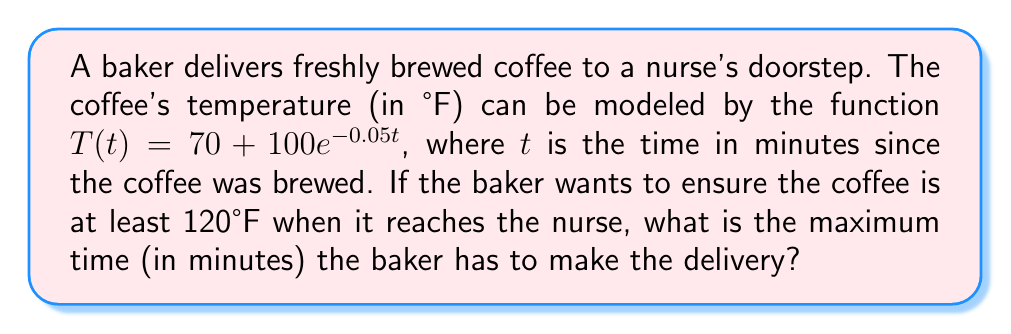What is the answer to this math problem? 1) We need to solve the equation $T(t) = 120$ to find the time when the coffee reaches 120°F.

2) Substitute the given function:
   $70 + 100e^{-0.05t} = 120$

3) Subtract 70 from both sides:
   $100e^{-0.05t} = 50$

4) Divide both sides by 100:
   $e^{-0.05t} = 0.5$

5) Take the natural logarithm of both sides:
   $\ln(e^{-0.05t}) = \ln(0.5)$

6) Simplify the left side using the property of logarithms:
   $-0.05t = \ln(0.5)$

7) Divide both sides by -0.05:
   $t = \frac{\ln(0.5)}{-0.05}$

8) Calculate the result:
   $t \approx 13.86$ minutes

9) Since we want the maximum time, we round down to ensure the temperature is at least 120°F.

Therefore, the baker has a maximum of 13 minutes to deliver the coffee.
Answer: 13 minutes 